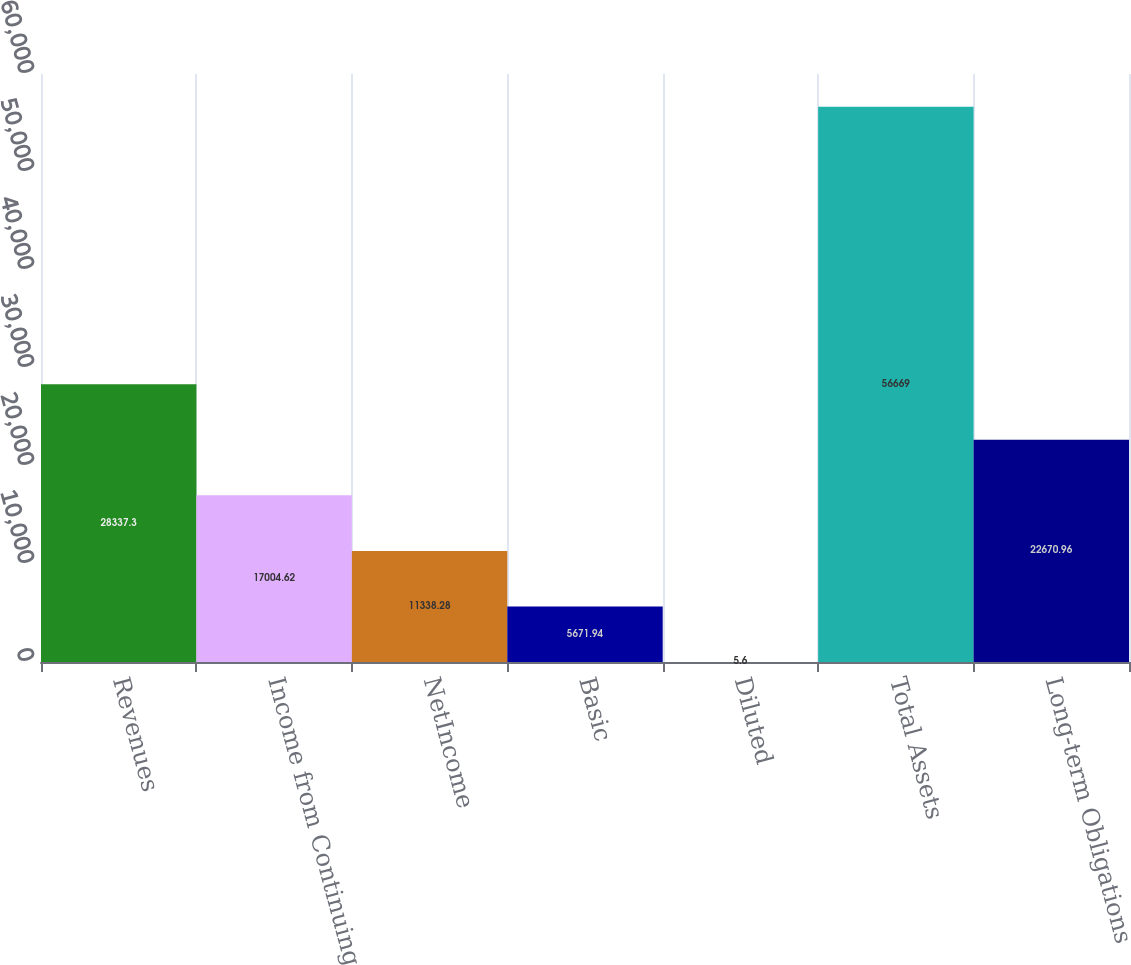Convert chart to OTSL. <chart><loc_0><loc_0><loc_500><loc_500><bar_chart><fcel>Revenues<fcel>Income from Continuing<fcel>NetIncome<fcel>Basic<fcel>Diluted<fcel>Total Assets<fcel>Long-term Obligations<nl><fcel>28337.3<fcel>17004.6<fcel>11338.3<fcel>5671.94<fcel>5.6<fcel>56669<fcel>22671<nl></chart> 